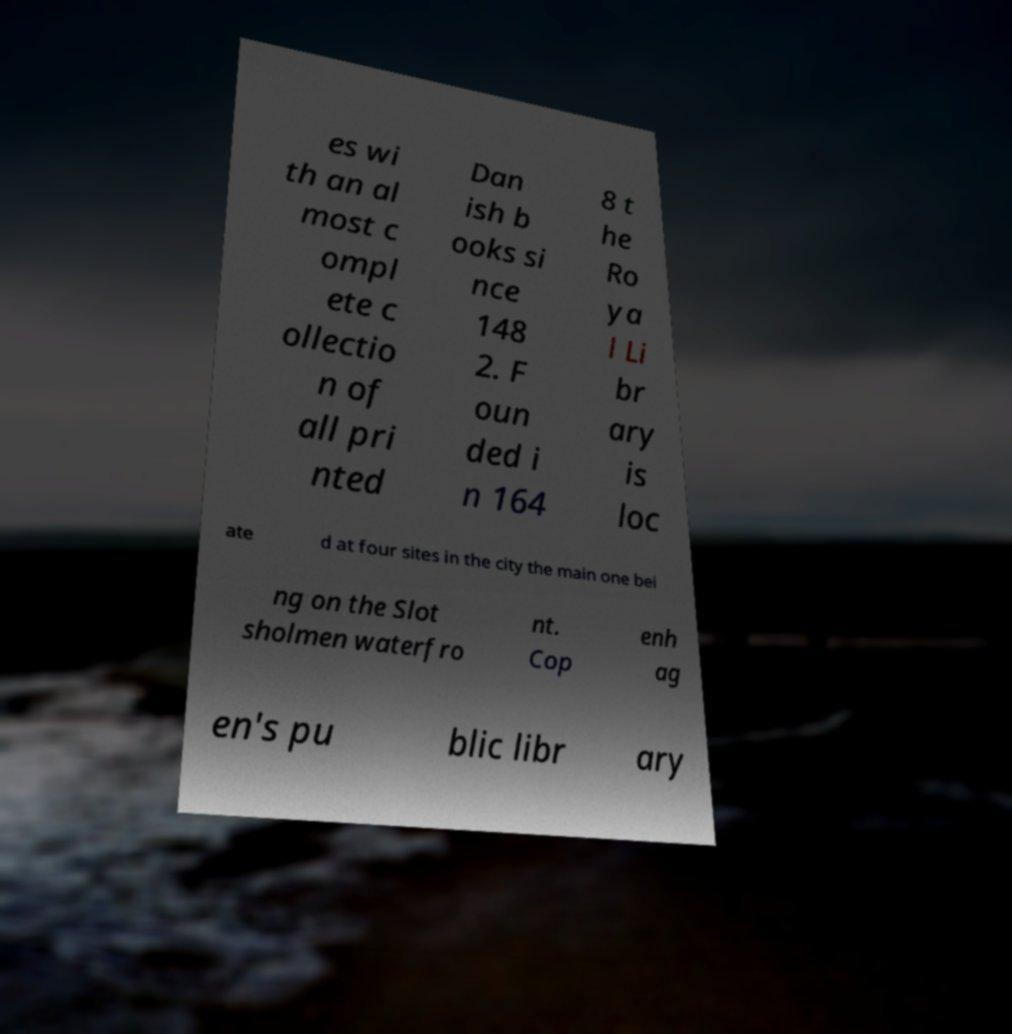Please read and relay the text visible in this image. What does it say? es wi th an al most c ompl ete c ollectio n of all pri nted Dan ish b ooks si nce 148 2. F oun ded i n 164 8 t he Ro ya l Li br ary is loc ate d at four sites in the city the main one bei ng on the Slot sholmen waterfro nt. Cop enh ag en's pu blic libr ary 